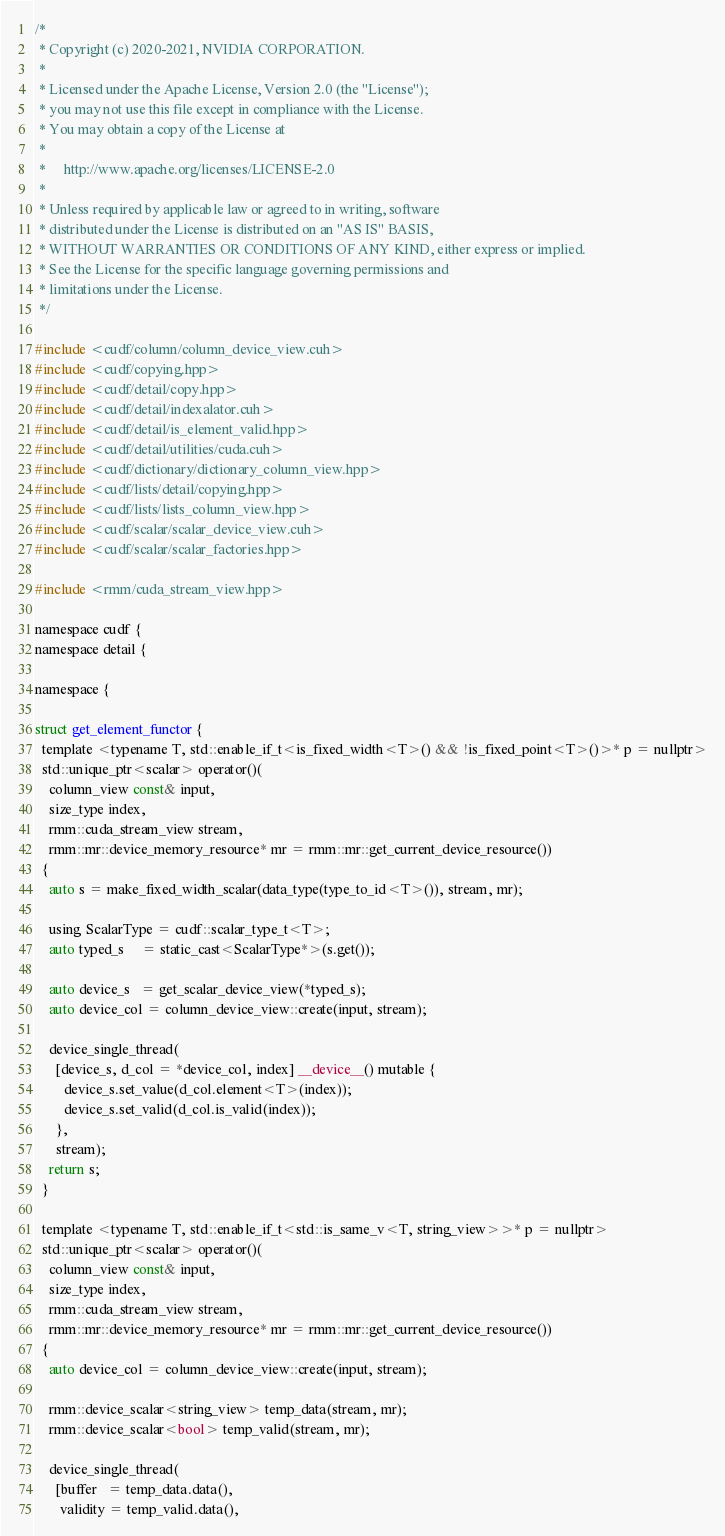<code> <loc_0><loc_0><loc_500><loc_500><_Cuda_>/*
 * Copyright (c) 2020-2021, NVIDIA CORPORATION.
 *
 * Licensed under the Apache License, Version 2.0 (the "License");
 * you may not use this file except in compliance with the License.
 * You may obtain a copy of the License at
 *
 *     http://www.apache.org/licenses/LICENSE-2.0
 *
 * Unless required by applicable law or agreed to in writing, software
 * distributed under the License is distributed on an "AS IS" BASIS,
 * WITHOUT WARRANTIES OR CONDITIONS OF ANY KIND, either express or implied.
 * See the License for the specific language governing permissions and
 * limitations under the License.
 */

#include <cudf/column/column_device_view.cuh>
#include <cudf/copying.hpp>
#include <cudf/detail/copy.hpp>
#include <cudf/detail/indexalator.cuh>
#include <cudf/detail/is_element_valid.hpp>
#include <cudf/detail/utilities/cuda.cuh>
#include <cudf/dictionary/dictionary_column_view.hpp>
#include <cudf/lists/detail/copying.hpp>
#include <cudf/lists/lists_column_view.hpp>
#include <cudf/scalar/scalar_device_view.cuh>
#include <cudf/scalar/scalar_factories.hpp>

#include <rmm/cuda_stream_view.hpp>

namespace cudf {
namespace detail {

namespace {

struct get_element_functor {
  template <typename T, std::enable_if_t<is_fixed_width<T>() && !is_fixed_point<T>()>* p = nullptr>
  std::unique_ptr<scalar> operator()(
    column_view const& input,
    size_type index,
    rmm::cuda_stream_view stream,
    rmm::mr::device_memory_resource* mr = rmm::mr::get_current_device_resource())
  {
    auto s = make_fixed_width_scalar(data_type(type_to_id<T>()), stream, mr);

    using ScalarType = cudf::scalar_type_t<T>;
    auto typed_s     = static_cast<ScalarType*>(s.get());

    auto device_s   = get_scalar_device_view(*typed_s);
    auto device_col = column_device_view::create(input, stream);

    device_single_thread(
      [device_s, d_col = *device_col, index] __device__() mutable {
        device_s.set_value(d_col.element<T>(index));
        device_s.set_valid(d_col.is_valid(index));
      },
      stream);
    return s;
  }

  template <typename T, std::enable_if_t<std::is_same_v<T, string_view>>* p = nullptr>
  std::unique_ptr<scalar> operator()(
    column_view const& input,
    size_type index,
    rmm::cuda_stream_view stream,
    rmm::mr::device_memory_resource* mr = rmm::mr::get_current_device_resource())
  {
    auto device_col = column_device_view::create(input, stream);

    rmm::device_scalar<string_view> temp_data(stream, mr);
    rmm::device_scalar<bool> temp_valid(stream, mr);

    device_single_thread(
      [buffer   = temp_data.data(),
       validity = temp_valid.data(),</code> 